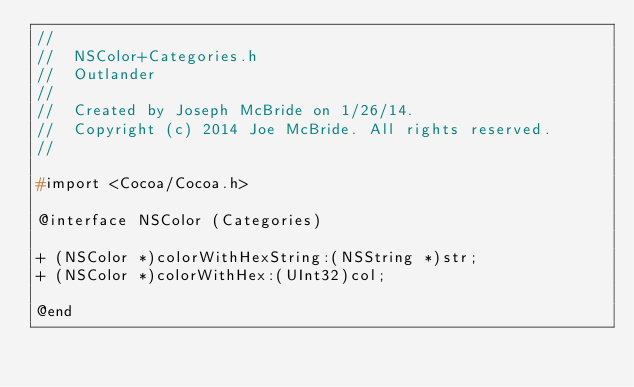<code> <loc_0><loc_0><loc_500><loc_500><_C_>//
//  NSColor+Categories.h
//  Outlander
//
//  Created by Joseph McBride on 1/26/14.
//  Copyright (c) 2014 Joe McBride. All rights reserved.
//

#import <Cocoa/Cocoa.h>

@interface NSColor (Categories)

+ (NSColor *)colorWithHexString:(NSString *)str;
+ (NSColor *)colorWithHex:(UInt32)col;

@end
</code> 